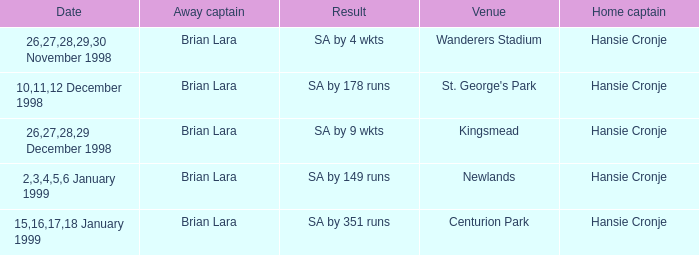Who is the away captain for Kingsmead? Brian Lara. 